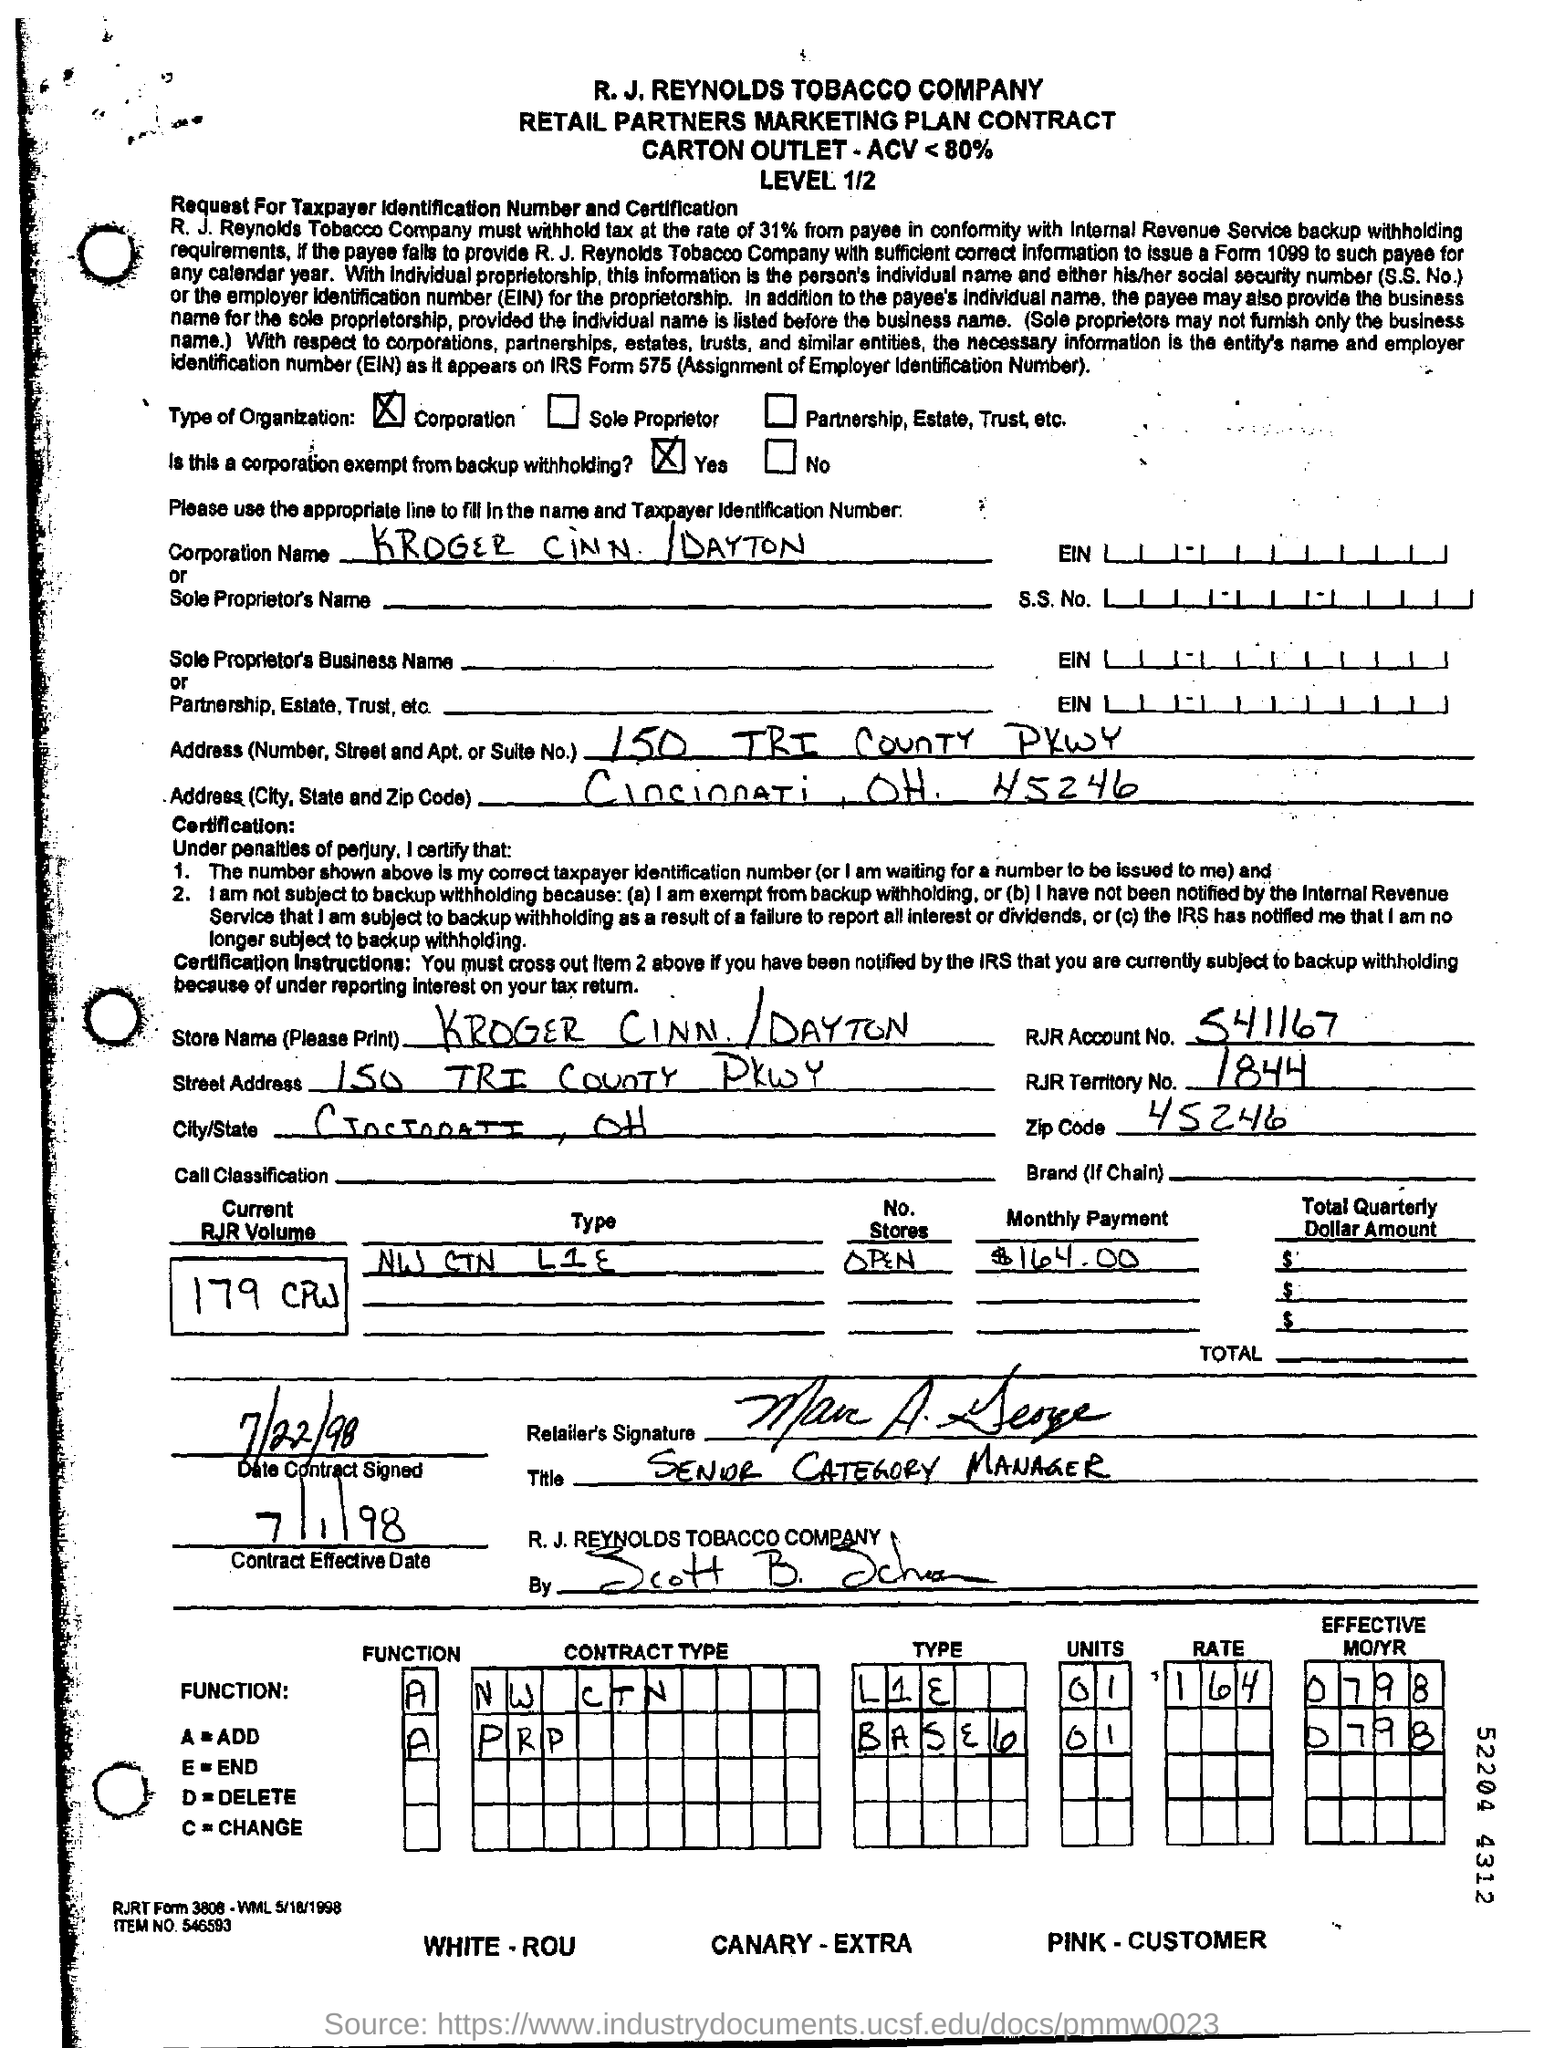Mention a couple of crucial points in this snapshot. The effective date of the contract is July 1, 1998. The RJR territory number is 1844. Yes, this is a corporation that is exempt from backup withholding. The monthly payment is $164.00. The function A is the addition of two numbers. 